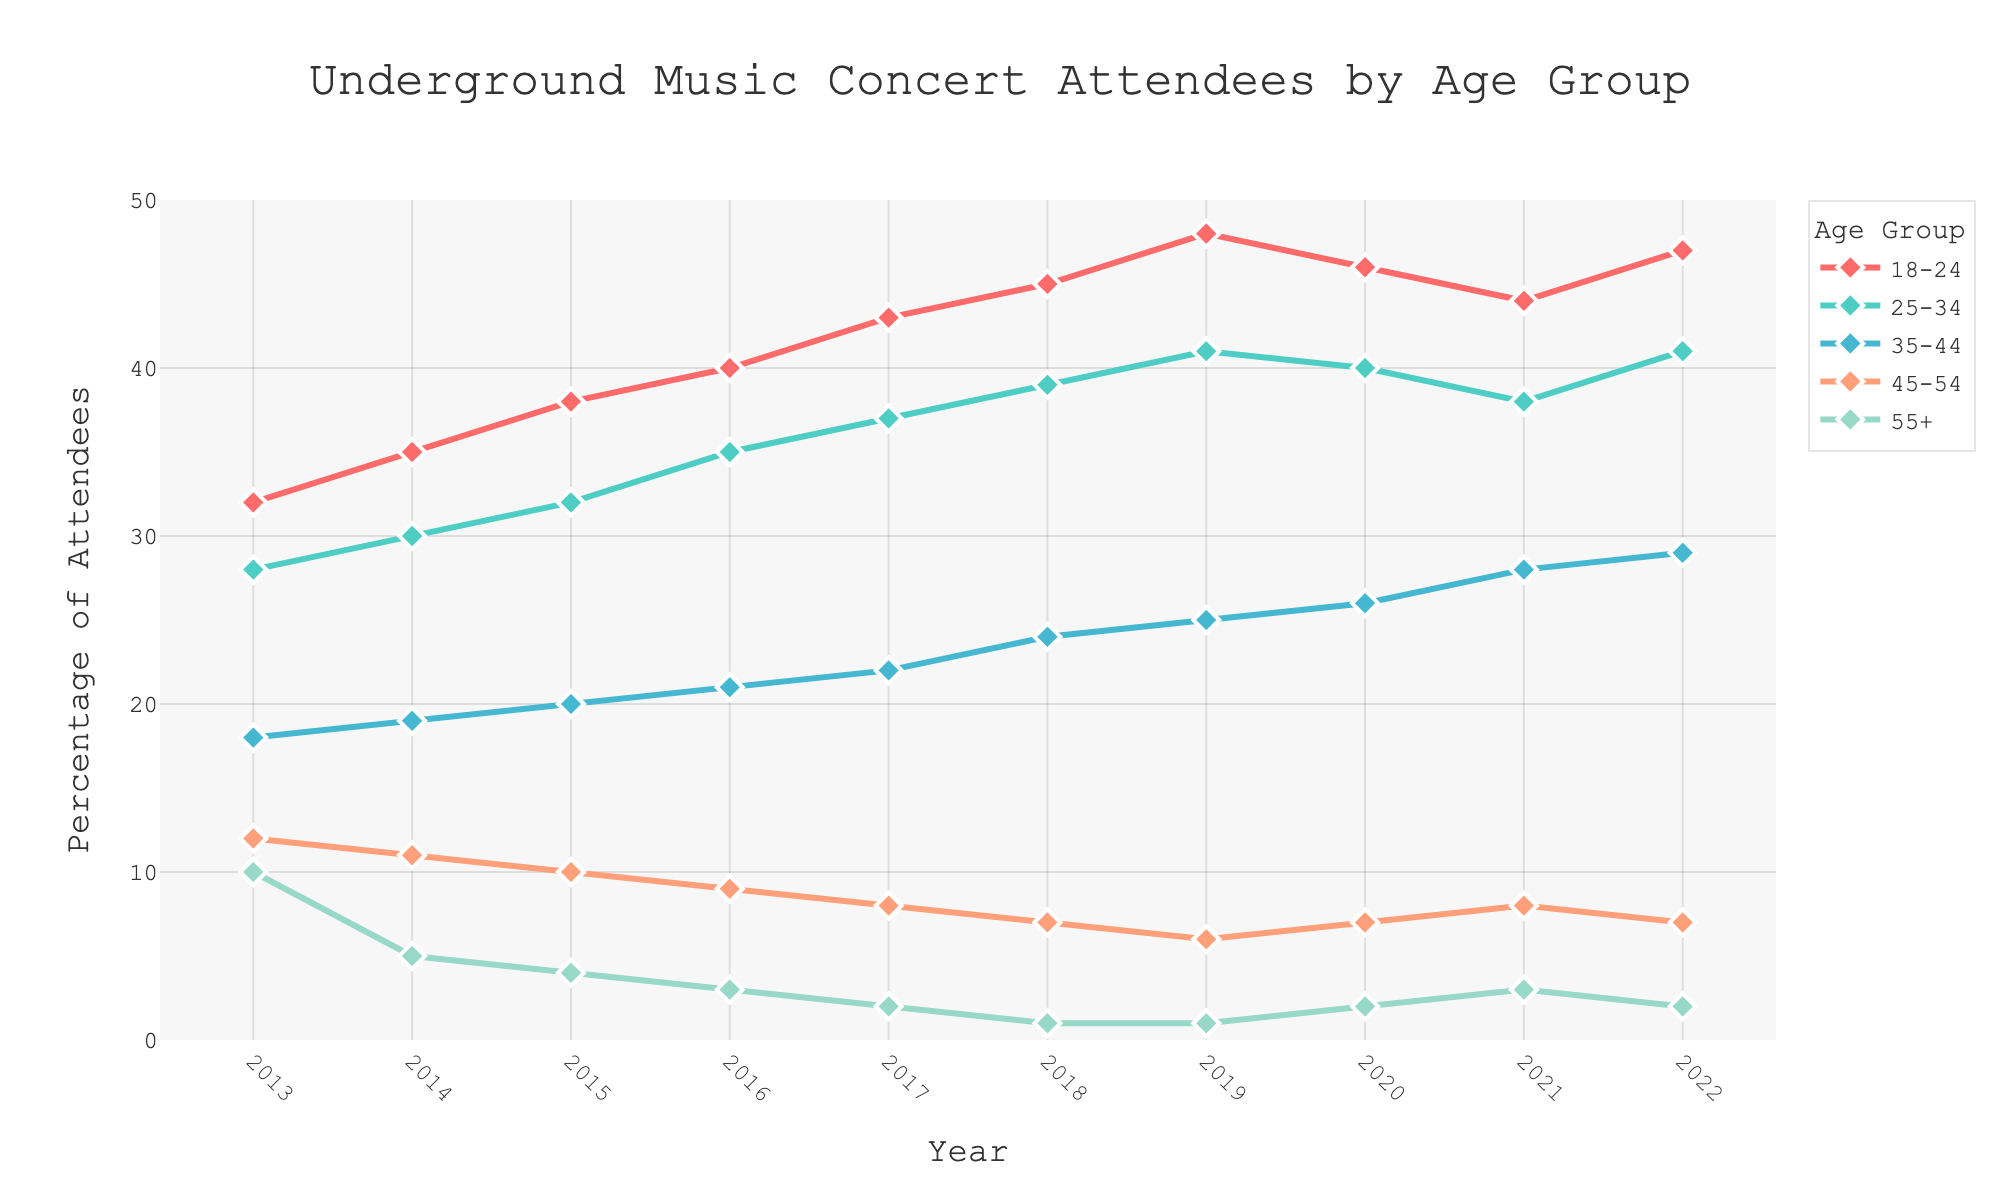What age group saw the highest increase in attendance from 2013 to 2022? Look at the initial and final values for each age group. Calculate the difference: 18-24 (47-32=15), 25-34 (41-28=13), 35-44 (29-18=11), 45-54 (7-12=-5), 55+ (2-10=-8). The highest increase is for the 18-24 age group.
Answer: 18-24 Which age group had the lowest percentage of attendees in 2022? Identify the values for each age group in 2022: 18-24 (47), 25-34 (41), 35-44 (29), 45-54 (7), 55+ (2). The lowest value is for the 55+ age group.
Answer: 55+ Did any age group experience a decrease in percentage from 2021 to 2022? Compare the 2021 and 2022 values for each age group: 18-24 (44 to 47, increase), 25-34 (38 to 41, increase), 35-44 (28 to 29, increase), 45-54 (7 to 7, same), 55+ (3 to 2, decrease). Only the 55+ group decreased.
Answer: 55+ Which two age groups had the most similar percentage of attendees in 2022? Identify the 2022 values: 18-24 (47), 25-34 (41), 35-44 (29), 45-54 (7), 55+ (2). The closest values are 18-24 and 25-34.
Answer: 18-24 and 25-34 What’s the average percentage of attendees for the 25-34 group from 2013 to 2022? Add the values for the 25-34 group: 28+30+32+35+37+39+41+40+38+41=361. Then divide by 10 (years).
Answer: 36.1 In which year did the 35-44 age group surpass the 45-54 age group in percentage? Compare values two by two: 2013 (18 vs. 12), 2014 (19 vs. 11), 2015 (20 vs. 10), 2016 (21 vs. 9), 2017 (22 vs. 8), 2018 (24 vs. 7), 2019 (25 vs. 6).  It is clear that 35-44 always had higher values than 45-54 since 2013.
Answer: 2013 By what percentage did the 55+ age group attendance drop from 2013 to 2018? Calculate the difference: 10 (2013) - 1 (2018) = 9. Then, calculate the percentage decrease: (9/10)*100 = 90%.
Answer: 90% Which age group had a consistent increase every year from 2013 to 2019? Calculate the year-on-year increases for each group and check for consistency: For 18-24, values increase each year from 32 to 48.
Answer: 18-24 